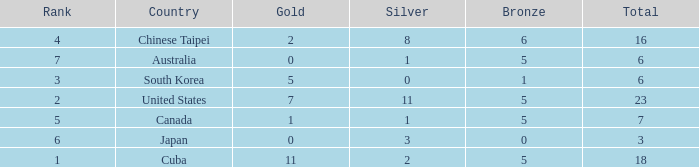What is the sum of the bronze medals when there were more than 2 silver medals and a rank larger than 6? None. 